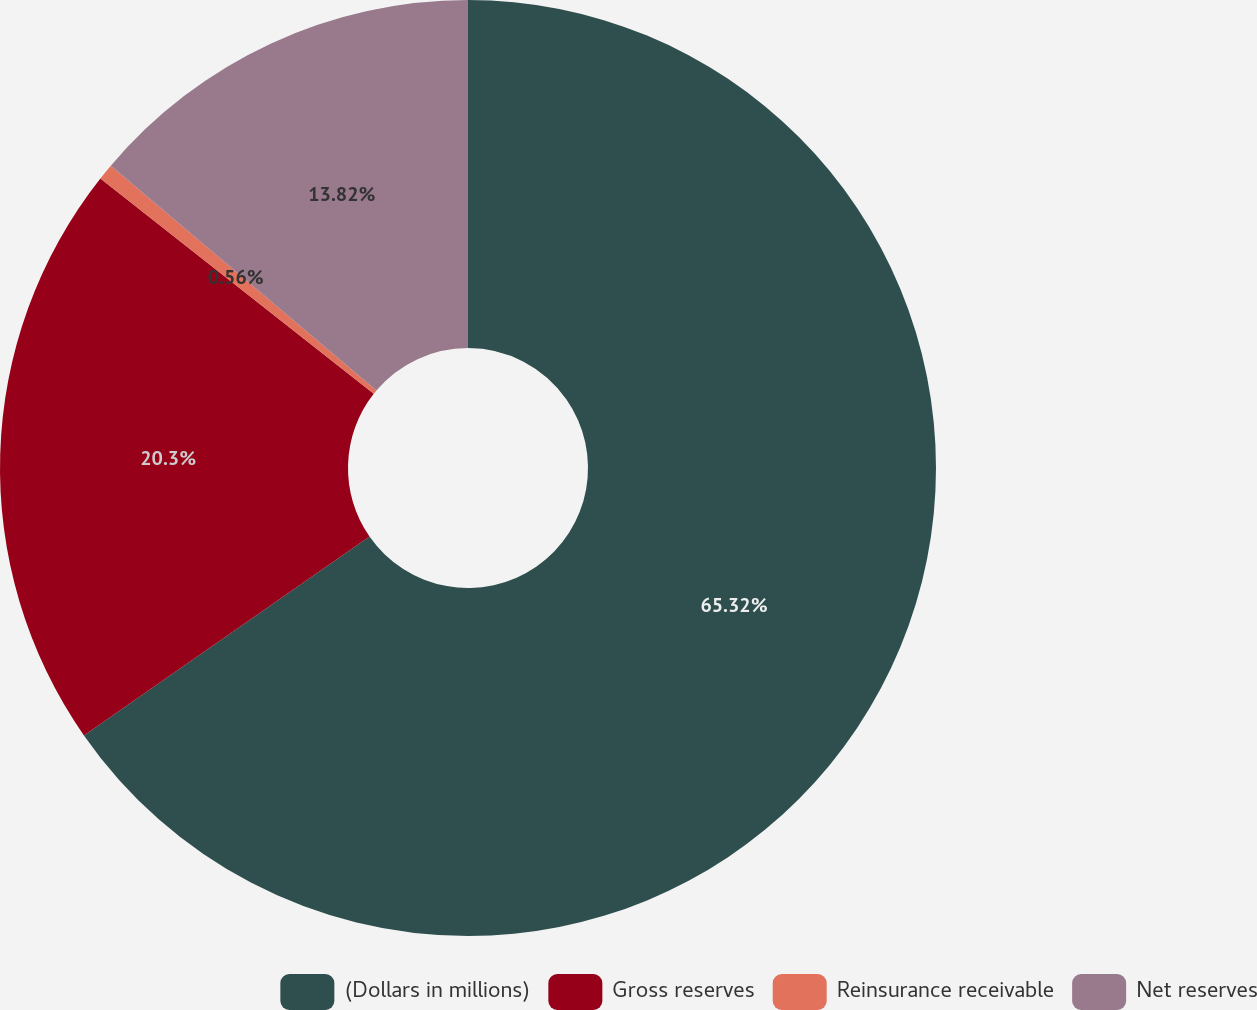<chart> <loc_0><loc_0><loc_500><loc_500><pie_chart><fcel>(Dollars in millions)<fcel>Gross reserves<fcel>Reinsurance receivable<fcel>Net reserves<nl><fcel>65.32%<fcel>20.3%<fcel>0.56%<fcel>13.82%<nl></chart> 